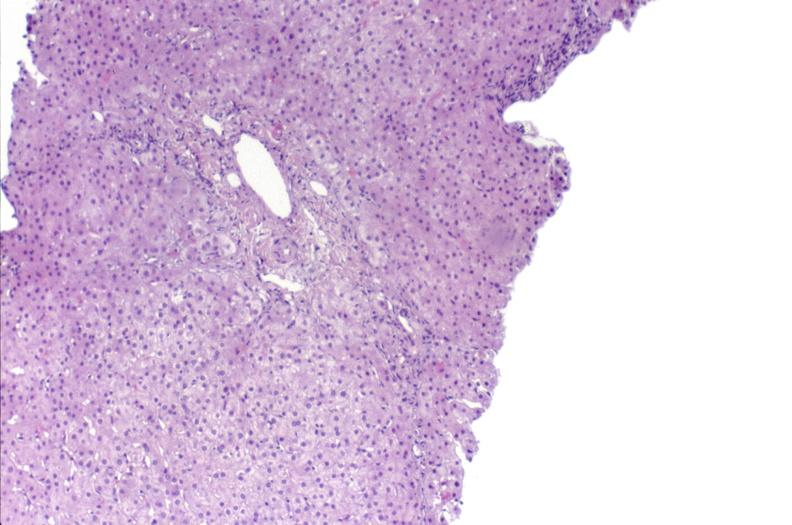s liver present?
Answer the question using a single word or phrase. Yes 